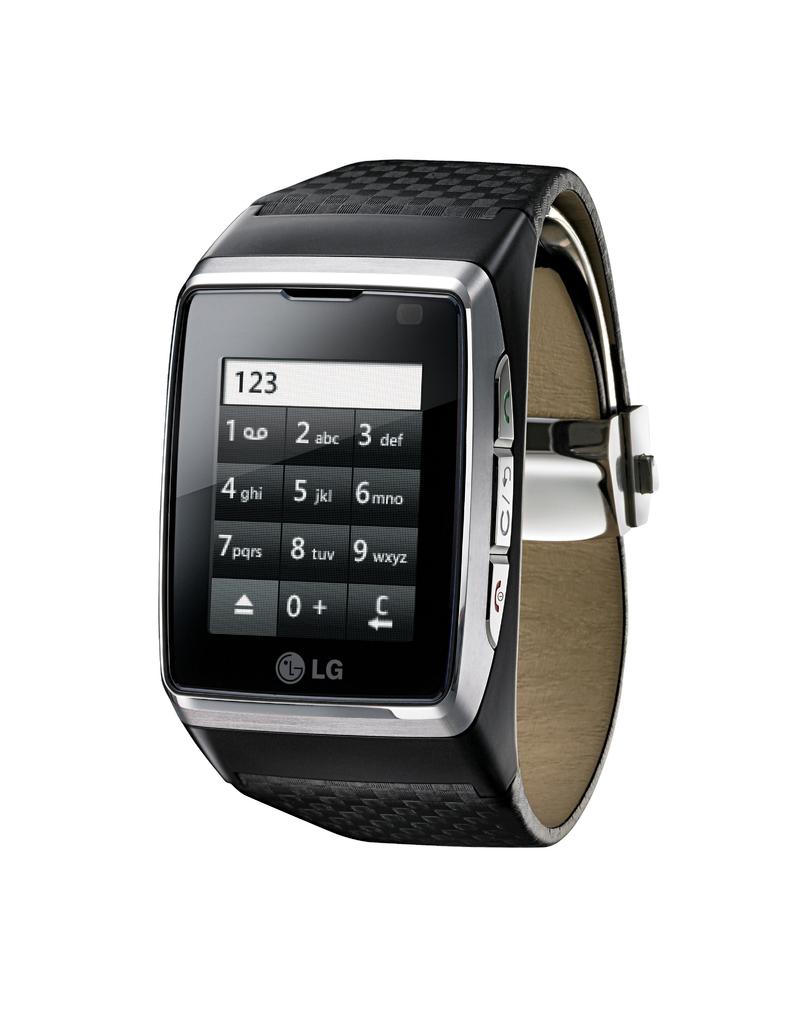What time does the watch say?
Provide a succinct answer. Unanswerable. 